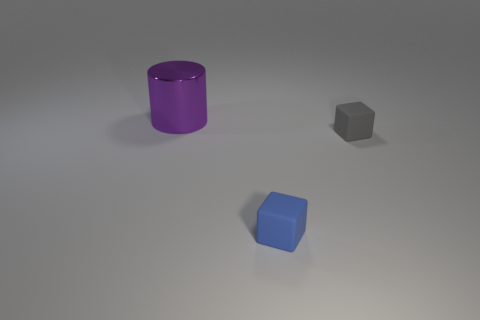What number of gray rubber things are to the left of the cube that is in front of the small gray matte block behind the tiny blue rubber cube?
Make the answer very short. 0. What is the shape of the large purple metallic thing?
Give a very brief answer. Cylinder. What number of other objects are the same material as the blue object?
Offer a terse response. 1. Does the blue rubber cube have the same size as the shiny object?
Offer a terse response. No. What shape is the matte thing left of the gray thing?
Offer a terse response. Cube. There is a matte object that is right of the small matte block that is in front of the gray object; what is its color?
Keep it short and to the point. Gray. There is a rubber object that is behind the small blue matte object; is it the same shape as the object that is to the left of the blue thing?
Your answer should be compact. No. There is a gray matte thing that is the same size as the blue thing; what is its shape?
Give a very brief answer. Cube. The small object that is the same material as the small gray block is what color?
Keep it short and to the point. Blue. Do the metallic thing and the tiny object to the right of the blue object have the same shape?
Keep it short and to the point. No. 